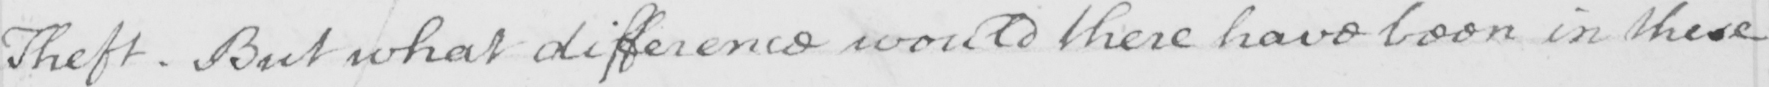Please transcribe the handwritten text in this image. Theft . But what difference would there have been in these 